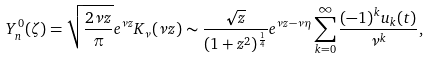Convert formula to latex. <formula><loc_0><loc_0><loc_500><loc_500>Y _ { n } ^ { 0 } ( \zeta ) = \sqrt { \frac { 2 \nu z } { \pi } } e ^ { \nu z } K _ { \nu } ( \nu z ) \sim \frac { \sqrt { z } } { ( 1 + z ^ { 2 } ) ^ { \frac { 1 } { 4 } } } e ^ { \nu z - \nu \eta } \sum _ { k = 0 } ^ { \infty } \frac { ( - 1 ) ^ { k } u _ { k } ( t ) } { \nu ^ { k } } ,</formula> 